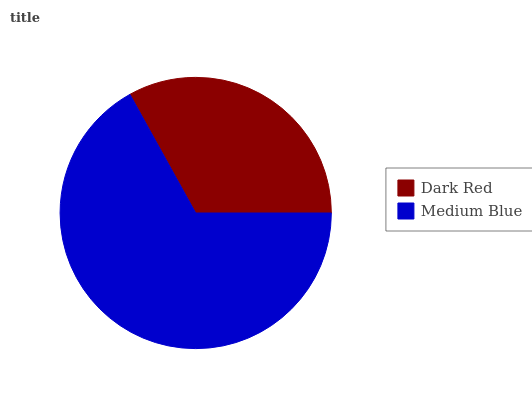Is Dark Red the minimum?
Answer yes or no. Yes. Is Medium Blue the maximum?
Answer yes or no. Yes. Is Medium Blue the minimum?
Answer yes or no. No. Is Medium Blue greater than Dark Red?
Answer yes or no. Yes. Is Dark Red less than Medium Blue?
Answer yes or no. Yes. Is Dark Red greater than Medium Blue?
Answer yes or no. No. Is Medium Blue less than Dark Red?
Answer yes or no. No. Is Medium Blue the high median?
Answer yes or no. Yes. Is Dark Red the low median?
Answer yes or no. Yes. Is Dark Red the high median?
Answer yes or no. No. Is Medium Blue the low median?
Answer yes or no. No. 